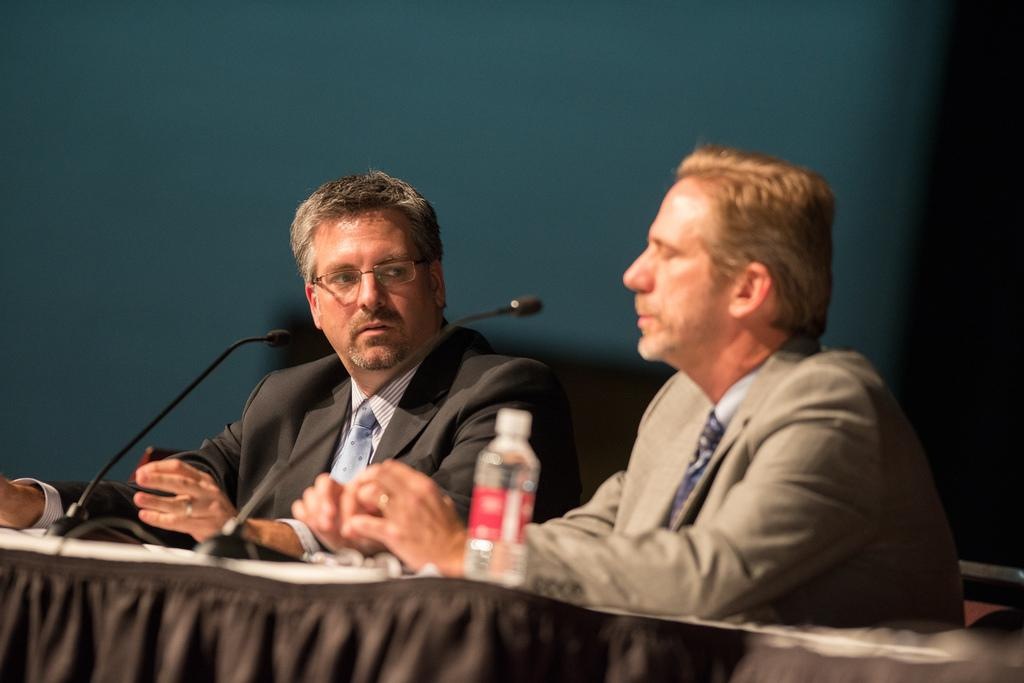How many people are present in the image? There are two persons sitting in the image. What objects are in front of the persons? There are mics in front of the persons. What can be seen on the table in the image? There is a bottle on the table. What colors are present in the background of the image? The background of the image has green and black colors. How many planes are flying in the image? There are no planes visible in the image. What type of trucks can be seen in the background of the image? There are no trucks present in the image; the background colors are green and black. 